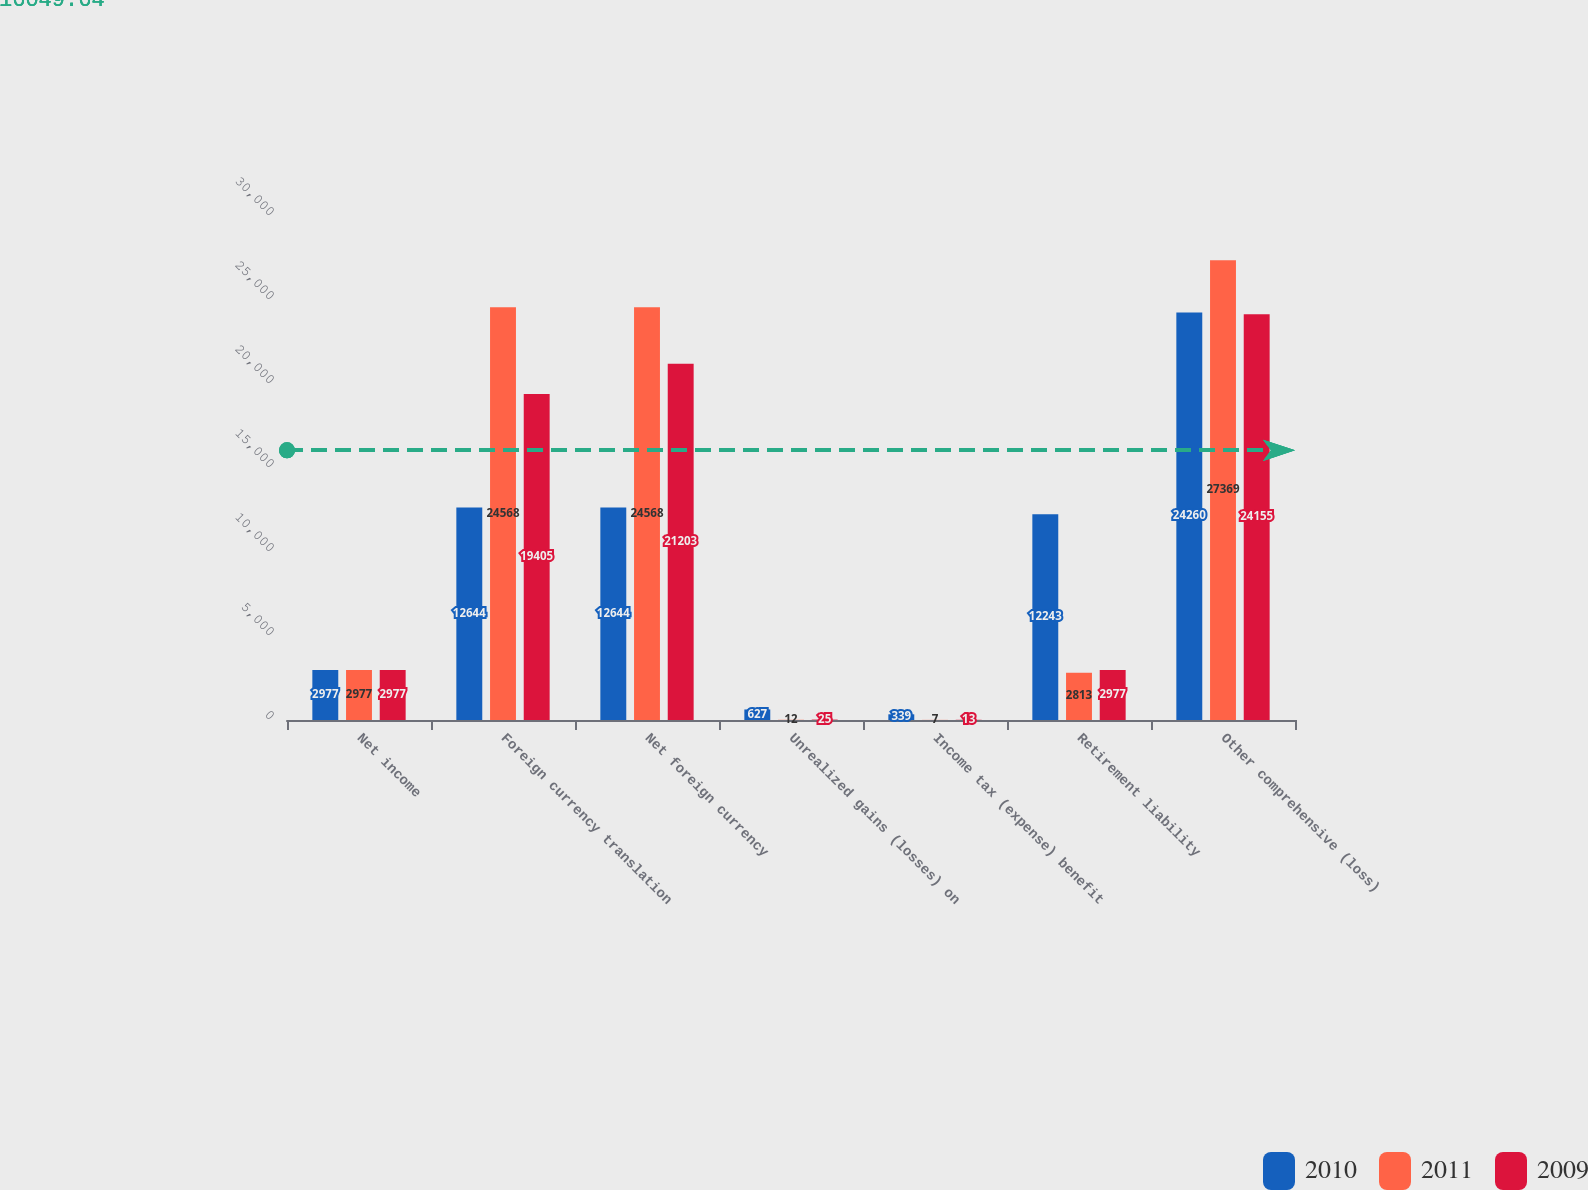Convert chart. <chart><loc_0><loc_0><loc_500><loc_500><stacked_bar_chart><ecel><fcel>Net income<fcel>Foreign currency translation<fcel>Net foreign currency<fcel>Unrealized gains (losses) on<fcel>Income tax (expense) benefit<fcel>Retirement liability<fcel>Other comprehensive (loss)<nl><fcel>2010<fcel>2977<fcel>12644<fcel>12644<fcel>627<fcel>339<fcel>12243<fcel>24260<nl><fcel>2011<fcel>2977<fcel>24568<fcel>24568<fcel>12<fcel>7<fcel>2813<fcel>27369<nl><fcel>2009<fcel>2977<fcel>19405<fcel>21203<fcel>25<fcel>13<fcel>2977<fcel>24155<nl></chart> 